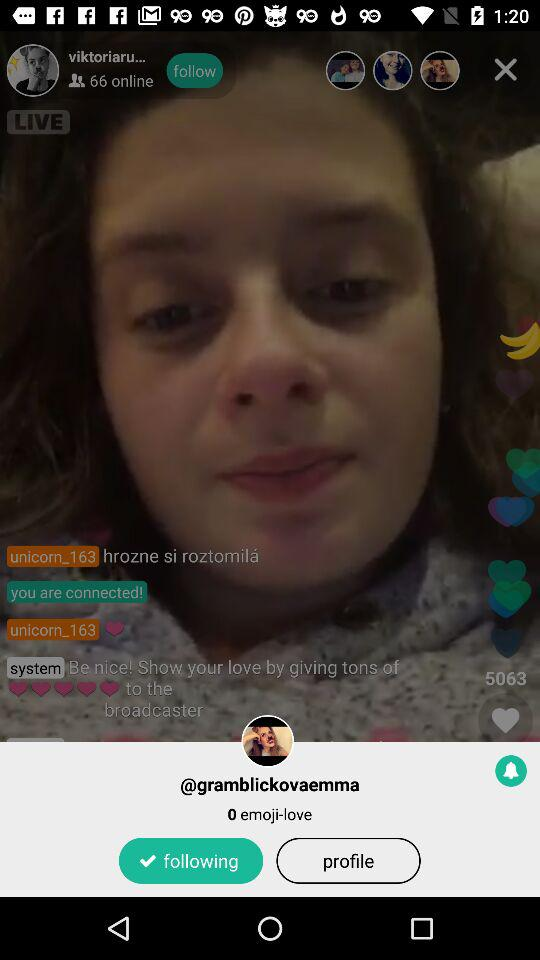How many "emoji-love" are there? There is 0 "emoji-love". 